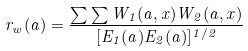<formula> <loc_0><loc_0><loc_500><loc_500>r _ { w } ( a ) = \frac { \sum \sum W _ { 1 } ( a , x ) W _ { 2 } ( a , x ) } { [ E _ { 1 } ( a ) E _ { 2 } ( a ) ] ^ { 1 / 2 } }</formula> 